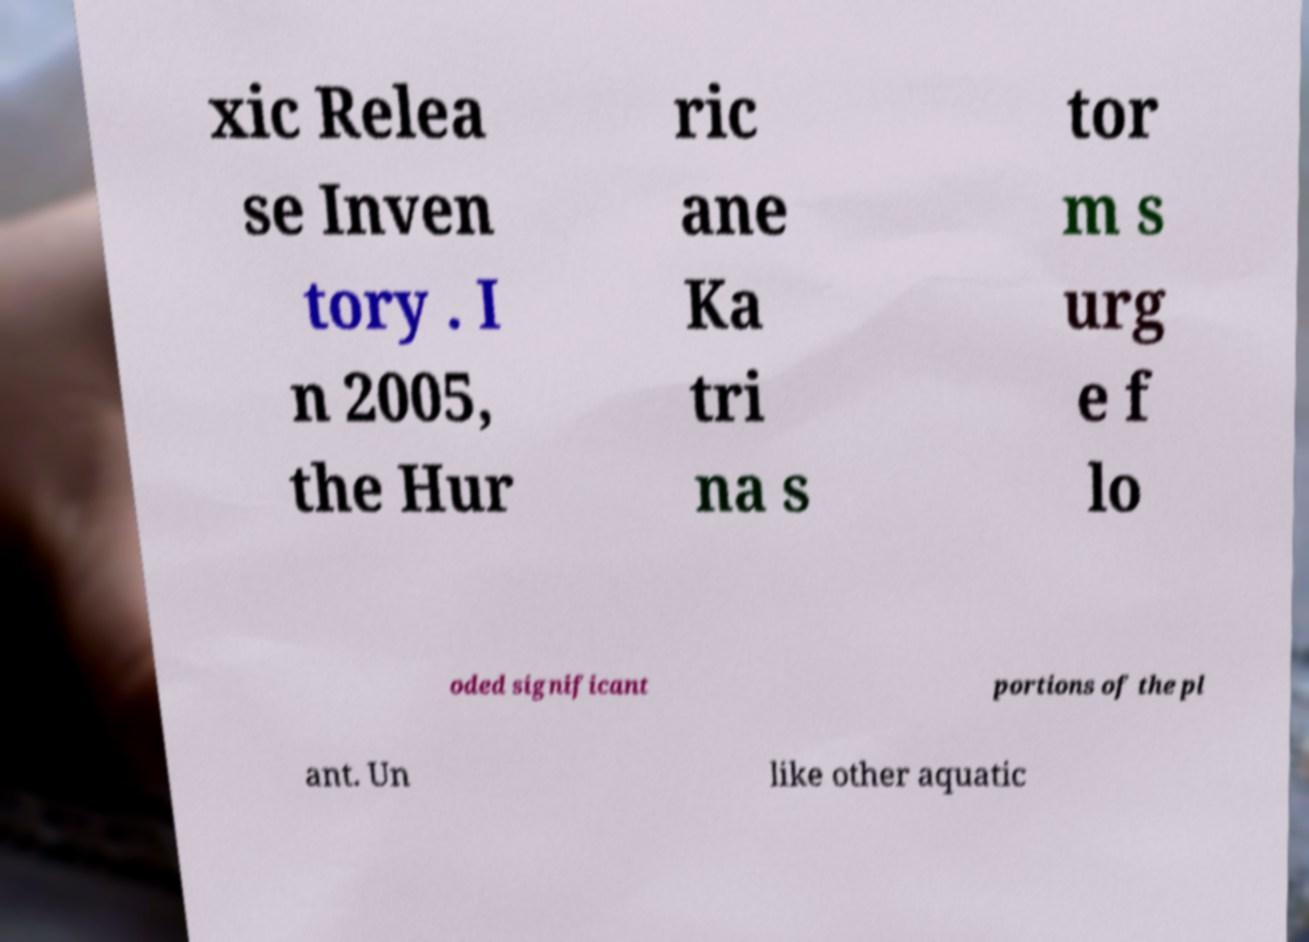There's text embedded in this image that I need extracted. Can you transcribe it verbatim? xic Relea se Inven tory . I n 2005, the Hur ric ane Ka tri na s tor m s urg e f lo oded significant portions of the pl ant. Un like other aquatic 